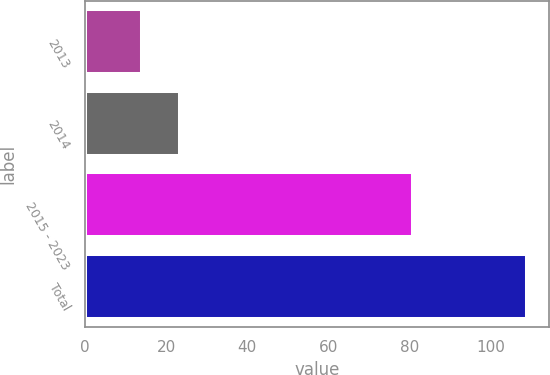<chart> <loc_0><loc_0><loc_500><loc_500><bar_chart><fcel>2013<fcel>2014<fcel>2015 - 2023<fcel>Total<nl><fcel>14<fcel>23.5<fcel>81<fcel>109<nl></chart> 